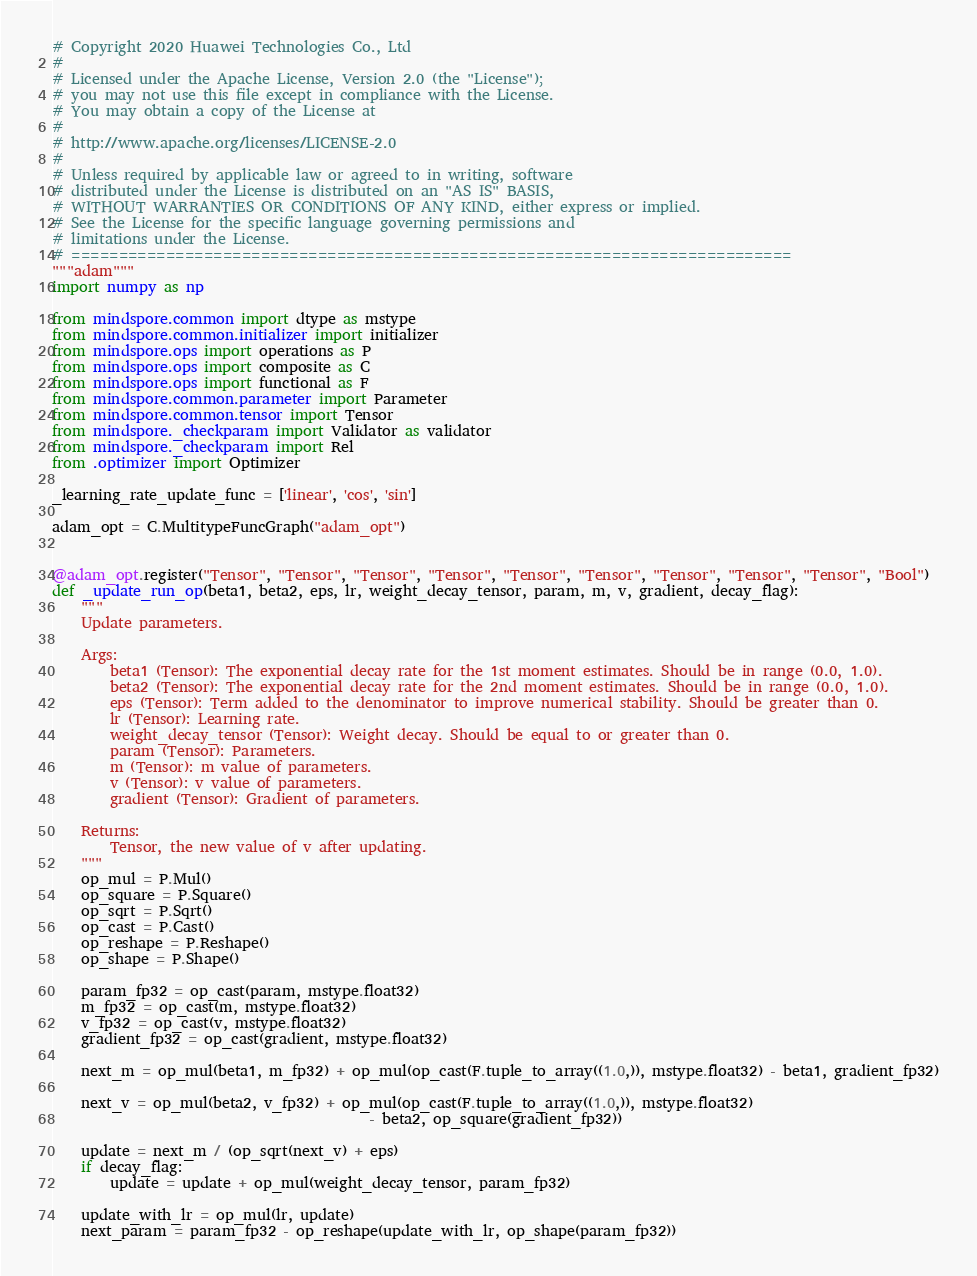<code> <loc_0><loc_0><loc_500><loc_500><_Python_># Copyright 2020 Huawei Technologies Co., Ltd
#
# Licensed under the Apache License, Version 2.0 (the "License");
# you may not use this file except in compliance with the License.
# You may obtain a copy of the License at
#
# http://www.apache.org/licenses/LICENSE-2.0
#
# Unless required by applicable law or agreed to in writing, software
# distributed under the License is distributed on an "AS IS" BASIS,
# WITHOUT WARRANTIES OR CONDITIONS OF ANY KIND, either express or implied.
# See the License for the specific language governing permissions and
# limitations under the License.
# ============================================================================
"""adam"""
import numpy as np

from mindspore.common import dtype as mstype
from mindspore.common.initializer import initializer
from mindspore.ops import operations as P
from mindspore.ops import composite as C
from mindspore.ops import functional as F
from mindspore.common.parameter import Parameter
from mindspore.common.tensor import Tensor
from mindspore._checkparam import Validator as validator
from mindspore._checkparam import Rel
from .optimizer import Optimizer

_learning_rate_update_func = ['linear', 'cos', 'sin']

adam_opt = C.MultitypeFuncGraph("adam_opt")


@adam_opt.register("Tensor", "Tensor", "Tensor", "Tensor", "Tensor", "Tensor", "Tensor", "Tensor", "Tensor", "Bool")
def _update_run_op(beta1, beta2, eps, lr, weight_decay_tensor, param, m, v, gradient, decay_flag):
    """
    Update parameters.

    Args:
        beta1 (Tensor): The exponential decay rate for the 1st moment estimates. Should be in range (0.0, 1.0).
        beta2 (Tensor): The exponential decay rate for the 2nd moment estimates. Should be in range (0.0, 1.0).
        eps (Tensor): Term added to the denominator to improve numerical stability. Should be greater than 0.
        lr (Tensor): Learning rate.
        weight_decay_tensor (Tensor): Weight decay. Should be equal to or greater than 0.
        param (Tensor): Parameters.
        m (Tensor): m value of parameters.
        v (Tensor): v value of parameters.
        gradient (Tensor): Gradient of parameters.

    Returns:
        Tensor, the new value of v after updating.
    """
    op_mul = P.Mul()
    op_square = P.Square()
    op_sqrt = P.Sqrt()
    op_cast = P.Cast()
    op_reshape = P.Reshape()
    op_shape = P.Shape()

    param_fp32 = op_cast(param, mstype.float32)
    m_fp32 = op_cast(m, mstype.float32)
    v_fp32 = op_cast(v, mstype.float32)
    gradient_fp32 = op_cast(gradient, mstype.float32)

    next_m = op_mul(beta1, m_fp32) + op_mul(op_cast(F.tuple_to_array((1.0,)), mstype.float32) - beta1, gradient_fp32)

    next_v = op_mul(beta2, v_fp32) + op_mul(op_cast(F.tuple_to_array((1.0,)), mstype.float32)
                                            - beta2, op_square(gradient_fp32))

    update = next_m / (op_sqrt(next_v) + eps)
    if decay_flag:
        update = update + op_mul(weight_decay_tensor, param_fp32)

    update_with_lr = op_mul(lr, update)
    next_param = param_fp32 - op_reshape(update_with_lr, op_shape(param_fp32))
</code> 